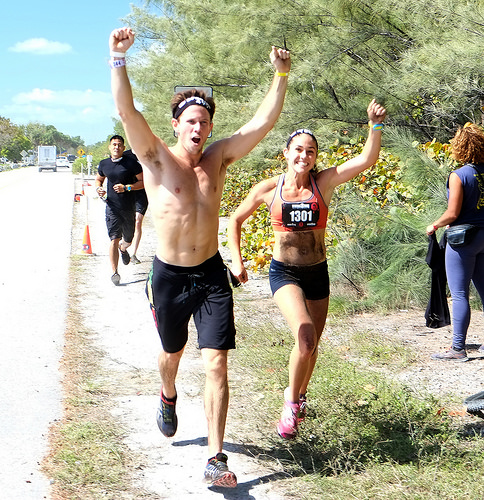<image>
Can you confirm if the traffic cone is behind the man? Yes. From this viewpoint, the traffic cone is positioned behind the man, with the man partially or fully occluding the traffic cone. 